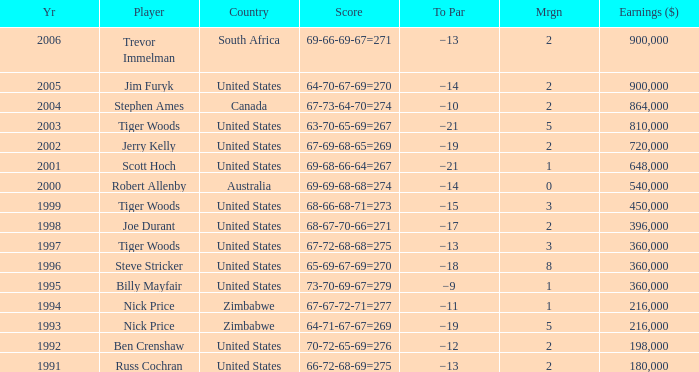Which Margin has a Country of united states, and a Score of 63-70-65-69=267? 5.0. 